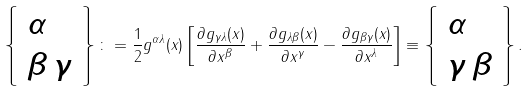<formula> <loc_0><loc_0><loc_500><loc_500>\left \{ \begin{array} { l } \alpha \\ \beta \, \gamma \end{array} \right \} \colon = \frac { 1 } { 2 } g ^ { \alpha \lambda } ( x ) \left [ \frac { \partial g _ { \gamma \lambda } ( x ) } { \partial x ^ { \beta } } + \frac { \partial g _ { \lambda \beta } ( x ) } { \partial x ^ { \gamma } } - \frac { \partial g _ { \beta \gamma } ( x ) } { \partial x ^ { \lambda } } \right ] \equiv \left \{ \begin{array} { l } \alpha \\ \gamma \, \beta \end{array} \right \} .</formula> 